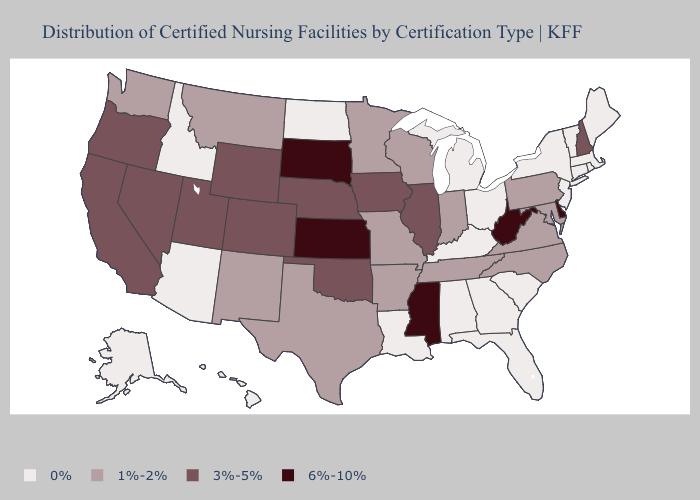What is the value of Missouri?
Short answer required. 1%-2%. Among the states that border Arkansas , does Missouri have the highest value?
Answer briefly. No. What is the value of Rhode Island?
Be succinct. 0%. Name the states that have a value in the range 6%-10%?
Write a very short answer. Delaware, Kansas, Mississippi, South Dakota, West Virginia. Which states have the highest value in the USA?
Answer briefly. Delaware, Kansas, Mississippi, South Dakota, West Virginia. Name the states that have a value in the range 6%-10%?
Keep it brief. Delaware, Kansas, Mississippi, South Dakota, West Virginia. Does New Mexico have the highest value in the USA?
Be succinct. No. What is the highest value in the USA?
Give a very brief answer. 6%-10%. What is the value of Virginia?
Keep it brief. 1%-2%. What is the lowest value in the USA?
Answer briefly. 0%. Name the states that have a value in the range 0%?
Give a very brief answer. Alabama, Alaska, Arizona, Connecticut, Florida, Georgia, Hawaii, Idaho, Kentucky, Louisiana, Maine, Massachusetts, Michigan, New Jersey, New York, North Dakota, Ohio, Rhode Island, South Carolina, Vermont. Which states hav the highest value in the Northeast?
Short answer required. New Hampshire. Does Oklahoma have the lowest value in the South?
Concise answer only. No. Does Montana have the lowest value in the USA?
Write a very short answer. No. Does Alabama have the lowest value in the USA?
Be succinct. Yes. 